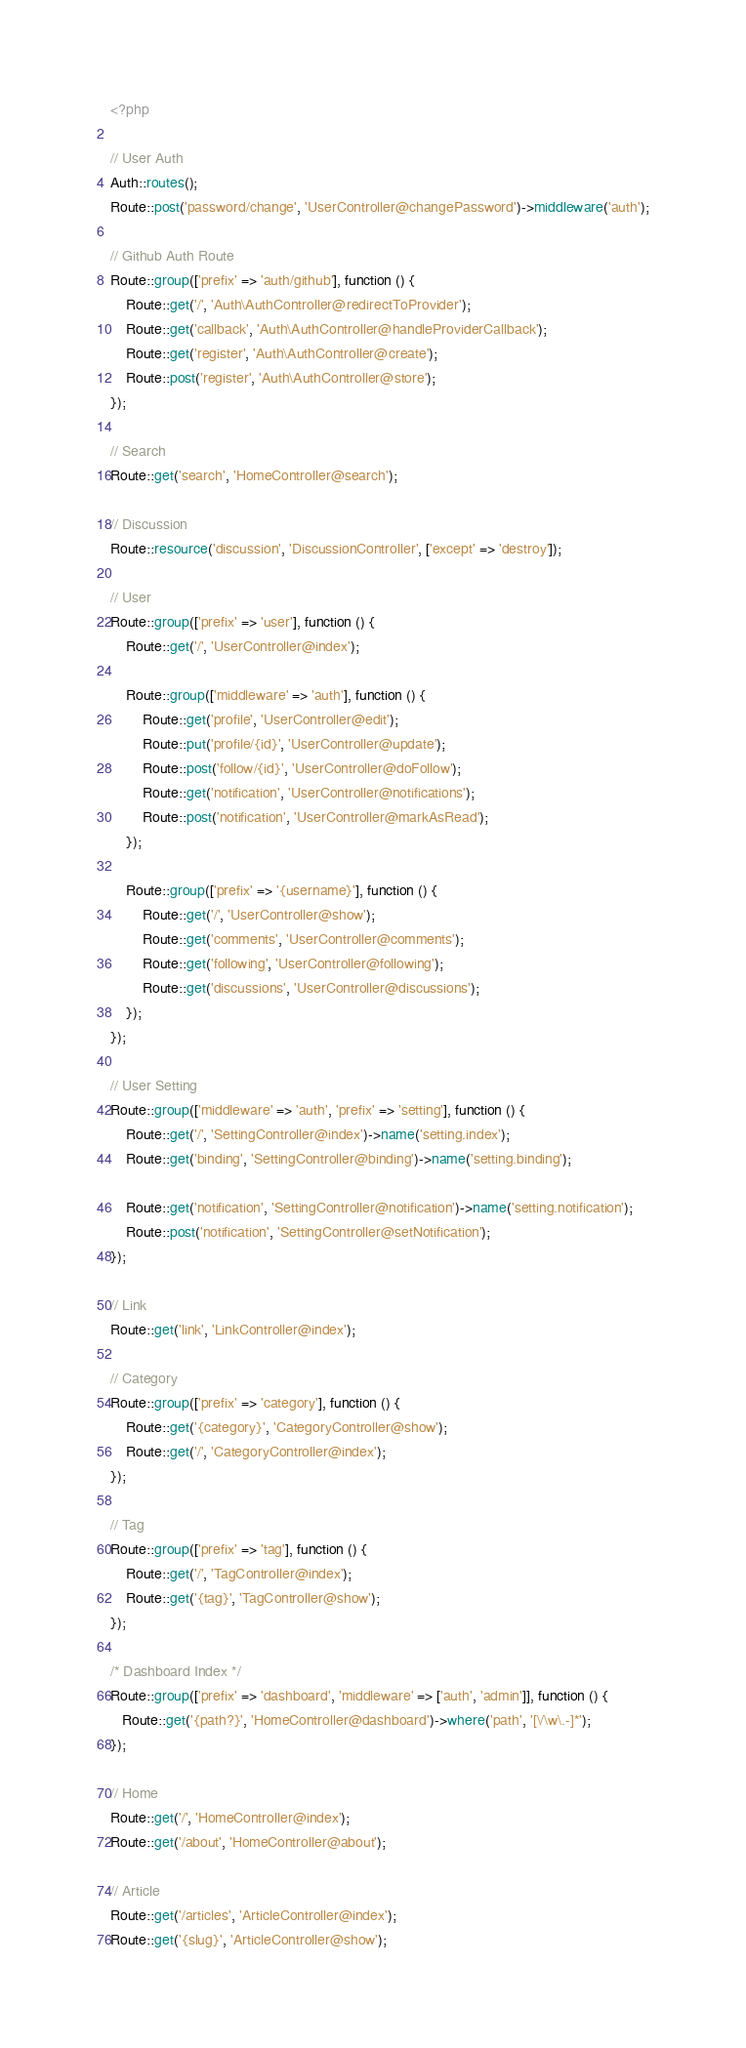<code> <loc_0><loc_0><loc_500><loc_500><_PHP_><?php

// User Auth
Auth::routes();
Route::post('password/change', 'UserController@changePassword')->middleware('auth');

// Github Auth Route
Route::group(['prefix' => 'auth/github'], function () {
    Route::get('/', 'Auth\AuthController@redirectToProvider');
    Route::get('callback', 'Auth\AuthController@handleProviderCallback');
    Route::get('register', 'Auth\AuthController@create');
    Route::post('register', 'Auth\AuthController@store');
});

// Search
Route::get('search', 'HomeController@search');

// Discussion
Route::resource('discussion', 'DiscussionController', ['except' => 'destroy']);

// User
Route::group(['prefix' => 'user'], function () {
    Route::get('/', 'UserController@index');

    Route::group(['middleware' => 'auth'], function () {
        Route::get('profile', 'UserController@edit');
        Route::put('profile/{id}', 'UserController@update');
        Route::post('follow/{id}', 'UserController@doFollow');
        Route::get('notification', 'UserController@notifications');
        Route::post('notification', 'UserController@markAsRead');
    });

    Route::group(['prefix' => '{username}'], function () {
        Route::get('/', 'UserController@show');
        Route::get('comments', 'UserController@comments');
        Route::get('following', 'UserController@following');
        Route::get('discussions', 'UserController@discussions');
    });
});

// User Setting
Route::group(['middleware' => 'auth', 'prefix' => 'setting'], function () {
    Route::get('/', 'SettingController@index')->name('setting.index');
    Route::get('binding', 'SettingController@binding')->name('setting.binding');

    Route::get('notification', 'SettingController@notification')->name('setting.notification');
    Route::post('notification', 'SettingController@setNotification');
});

// Link
Route::get('link', 'LinkController@index');

// Category
Route::group(['prefix' => 'category'], function () {
    Route::get('{category}', 'CategoryController@show');
    Route::get('/', 'CategoryController@index');
});

// Tag
Route::group(['prefix' => 'tag'], function () {
    Route::get('/', 'TagController@index');
    Route::get('{tag}', 'TagController@show');
});

/* Dashboard Index */
Route::group(['prefix' => 'dashboard', 'middleware' => ['auth', 'admin']], function () {
   Route::get('{path?}', 'HomeController@dashboard')->where('path', '[\/\w\.-]*');
});

// Home
Route::get('/', 'HomeController@index');
Route::get('/about', 'HomeController@about');

// Article
Route::get('/articles', 'ArticleController@index');
Route::get('{slug}', 'ArticleController@show');</code> 